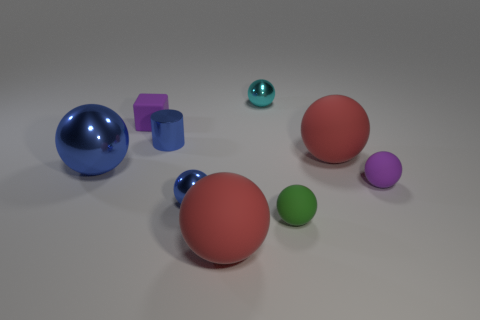Subtract all blue spheres. How many spheres are left? 5 Subtract all tiny purple balls. How many balls are left? 6 Subtract all gray spheres. Subtract all cyan blocks. How many spheres are left? 7 Add 1 large things. How many objects exist? 10 Subtract all cylinders. How many objects are left? 8 Add 4 matte blocks. How many matte blocks exist? 5 Subtract 1 blue cylinders. How many objects are left? 8 Subtract all tiny blue things. Subtract all cyan shiny balls. How many objects are left? 6 Add 8 tiny matte spheres. How many tiny matte spheres are left? 10 